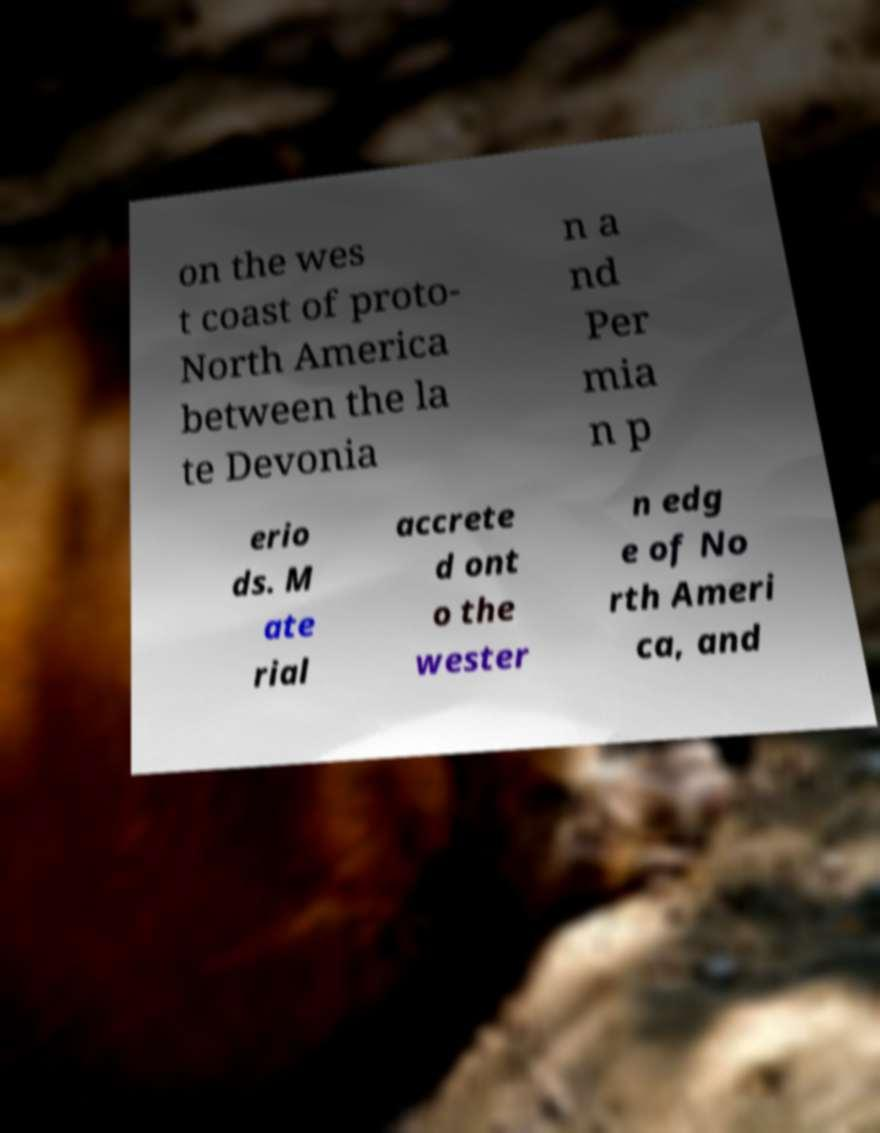I need the written content from this picture converted into text. Can you do that? on the wes t coast of proto- North America between the la te Devonia n a nd Per mia n p erio ds. M ate rial accrete d ont o the wester n edg e of No rth Ameri ca, and 